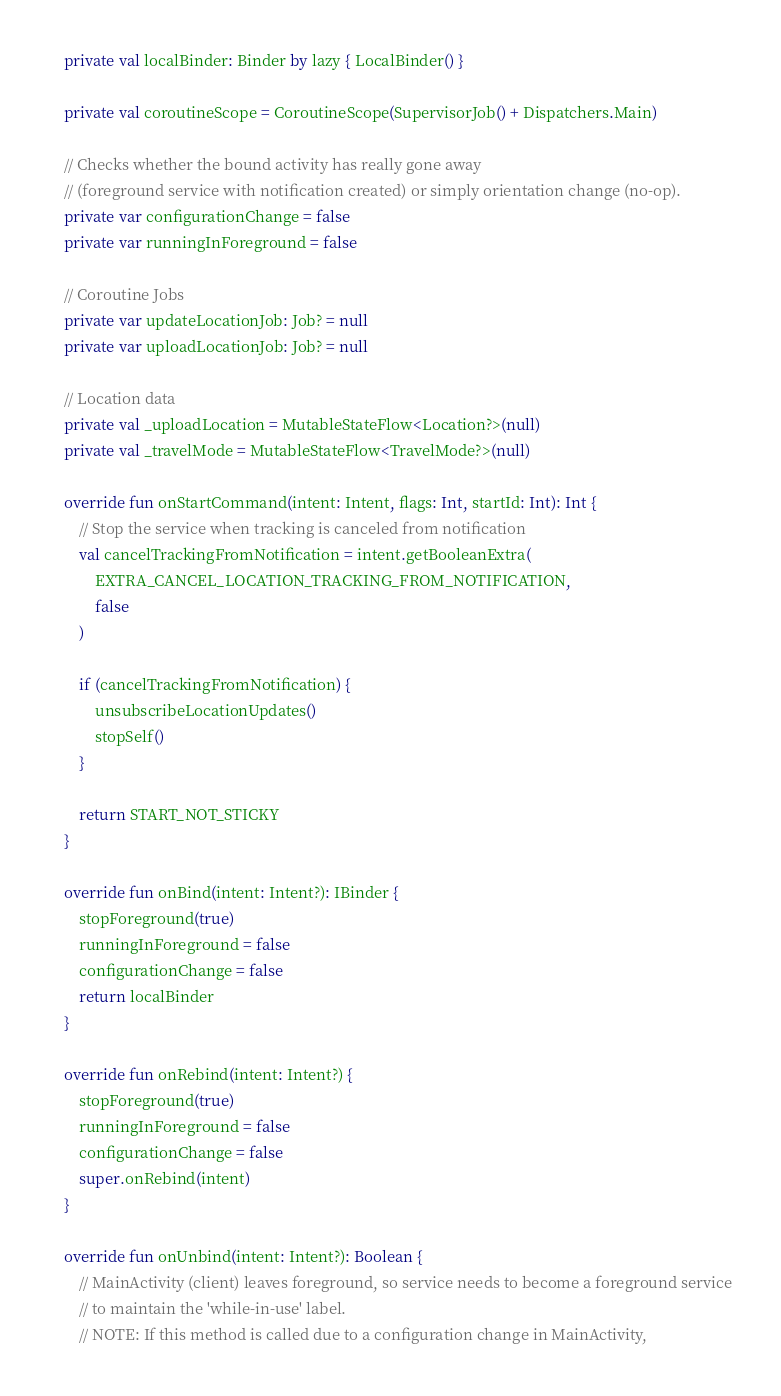Convert code to text. <code><loc_0><loc_0><loc_500><loc_500><_Kotlin_>
    private val localBinder: Binder by lazy { LocalBinder() }

    private val coroutineScope = CoroutineScope(SupervisorJob() + Dispatchers.Main)

    // Checks whether the bound activity has really gone away
    // (foreground service with notification created) or simply orientation change (no-op).
    private var configurationChange = false
    private var runningInForeground = false

    // Coroutine Jobs
    private var updateLocationJob: Job? = null
    private var uploadLocationJob: Job? = null

    // Location data
    private val _uploadLocation = MutableStateFlow<Location?>(null)
    private val _travelMode = MutableStateFlow<TravelMode?>(null)

    override fun onStartCommand(intent: Intent, flags: Int, startId: Int): Int {
        // Stop the service when tracking is canceled from notification
        val cancelTrackingFromNotification = intent.getBooleanExtra(
            EXTRA_CANCEL_LOCATION_TRACKING_FROM_NOTIFICATION,
            false
        )

        if (cancelTrackingFromNotification) {
            unsubscribeLocationUpdates()
            stopSelf()
        }

        return START_NOT_STICKY
    }

    override fun onBind(intent: Intent?): IBinder {
        stopForeground(true)
        runningInForeground = false
        configurationChange = false
        return localBinder
    }

    override fun onRebind(intent: Intent?) {
        stopForeground(true)
        runningInForeground = false
        configurationChange = false
        super.onRebind(intent)
    }

    override fun onUnbind(intent: Intent?): Boolean {
        // MainActivity (client) leaves foreground, so service needs to become a foreground service
        // to maintain the 'while-in-use' label.
        // NOTE: If this method is called due to a configuration change in MainActivity,</code> 